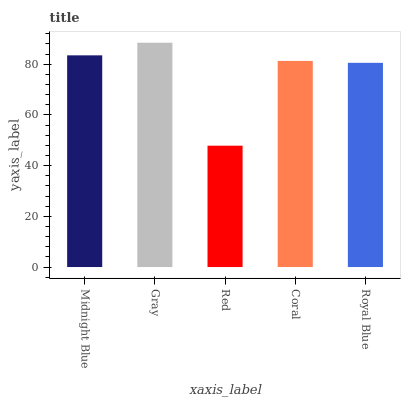Is Red the minimum?
Answer yes or no. Yes. Is Gray the maximum?
Answer yes or no. Yes. Is Gray the minimum?
Answer yes or no. No. Is Red the maximum?
Answer yes or no. No. Is Gray greater than Red?
Answer yes or no. Yes. Is Red less than Gray?
Answer yes or no. Yes. Is Red greater than Gray?
Answer yes or no. No. Is Gray less than Red?
Answer yes or no. No. Is Coral the high median?
Answer yes or no. Yes. Is Coral the low median?
Answer yes or no. Yes. Is Gray the high median?
Answer yes or no. No. Is Midnight Blue the low median?
Answer yes or no. No. 